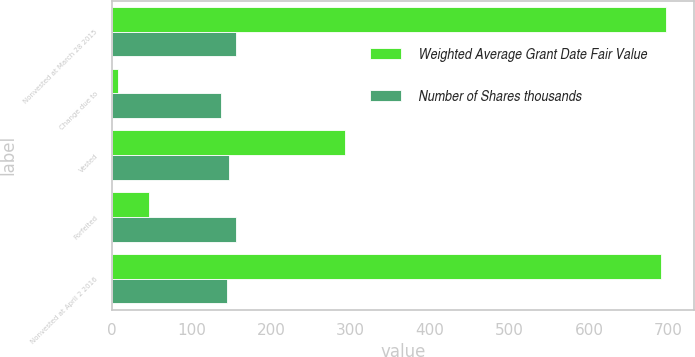Convert chart to OTSL. <chart><loc_0><loc_0><loc_500><loc_500><stacked_bar_chart><ecel><fcel>Nonvested at March 28 2015<fcel>Change due to<fcel>Vested<fcel>Forfeited<fcel>Nonvested at April 2 2016<nl><fcel>Weighted Average Grant Date Fair Value<fcel>697<fcel>8<fcel>293<fcel>46<fcel>691<nl><fcel>Number of Shares thousands<fcel>155.47<fcel>137.08<fcel>147.26<fcel>155.61<fcel>144.81<nl></chart> 